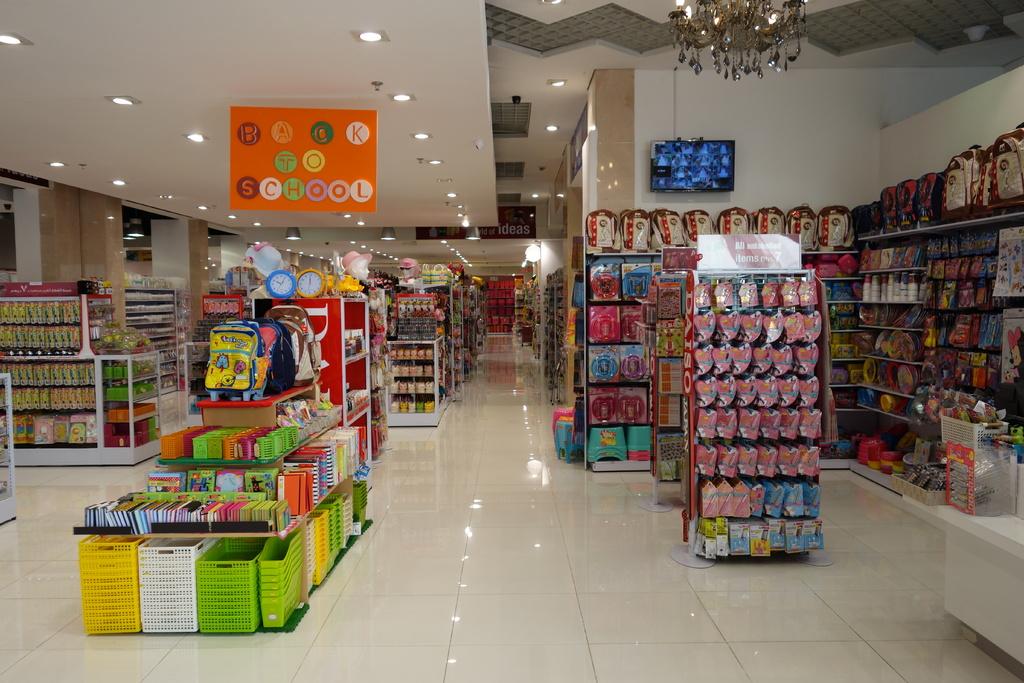What does the large overhanging orange sign say its going back too?
Your response must be concise. School. 